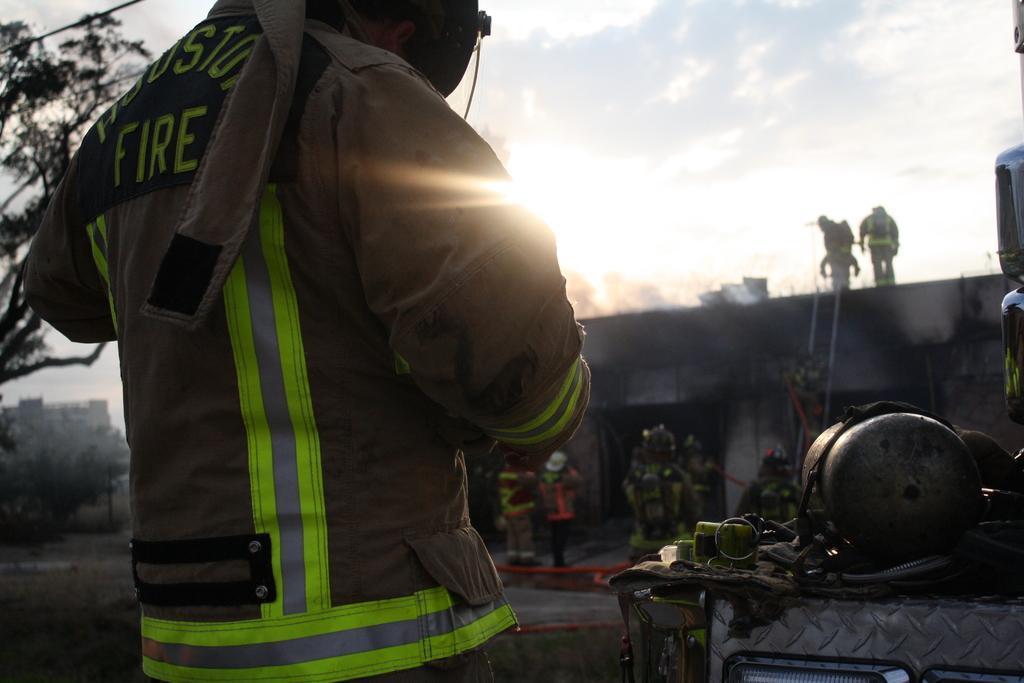Can you describe this image briefly? In this image, we can see a person is standing. On the right side, we can see few objects. Background we can see houses, trees, building, few people, ladder, pipes and sky. 